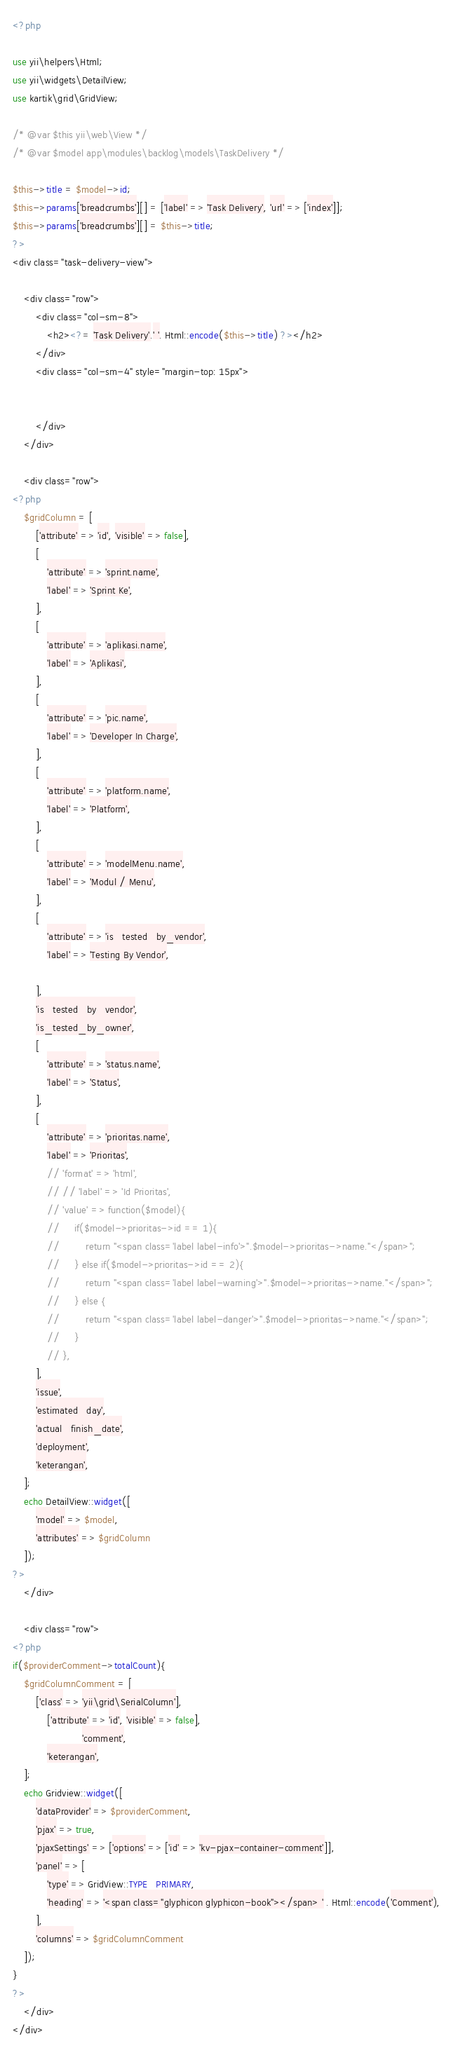<code> <loc_0><loc_0><loc_500><loc_500><_PHP_><?php

use yii\helpers\Html;
use yii\widgets\DetailView;
use kartik\grid\GridView;

/* @var $this yii\web\View */
/* @var $model app\modules\backlog\models\TaskDelivery */

$this->title = $model->id;
$this->params['breadcrumbs'][] = ['label' => 'Task Delivery', 'url' => ['index']];
$this->params['breadcrumbs'][] = $this->title;
?>
<div class="task-delivery-view">

    <div class="row">
        <div class="col-sm-8">
            <h2><?= 'Task Delivery'.' '. Html::encode($this->title) ?></h2>
        </div>
        <div class="col-sm-4" style="margin-top: 15px">

            
        </div>
    </div>

    <div class="row">
<?php 
    $gridColumn = [
        ['attribute' => 'id', 'visible' => false],
        [
            'attribute' => 'sprint.name',
            'label' => 'Sprint Ke',
        ],
        [
            'attribute' => 'aplikasi.name',
            'label' => 'Aplikasi',
        ],
        [
            'attribute' => 'pic.name',
            'label' => 'Developer In Charge',
        ],
        [
            'attribute' => 'platform.name',
            'label' => 'Platform',
        ],
        [
            'attribute' => 'modelMenu.name',
            'label' => 'Modul / Menu',
        ],
        [
            'attribute' => 'is_tested_by_vendor',
            'label' => 'Testing By Vendor',
            
        ],
        'is_tested_by_vendor',
        'is_tested_by_owner',
        [
            'attribute' => 'status.name',
            'label' => 'Status',
        ],
        [
            'attribute' => 'prioritas.name',
            'label' => 'Prioritas',
            // 'format' => 'html',
            // // 'label' => 'Id Prioritas',
            // 'value' => function($model){
            //     if($model->prioritas->id == 1){
            //         return "<span class='label label-info'>".$model->prioritas->name."</span>";
            //     } else if($model->prioritas->id == 2){
            //         return "<span class='label label-warning'>".$model->prioritas->name."</span>";
            //     } else {
            //         return "<span class='label label-danger'>".$model->prioritas->name."</span>";
            //     }
            // },
        ],
        'issue',
        'estimated_day',
        'actual_finish_date',
        'deployment',
        'keterangan',
    ];
    echo DetailView::widget([
        'model' => $model,
        'attributes' => $gridColumn
    ]); 
?>
    </div>
    
    <div class="row">
<?php
if($providerComment->totalCount){
    $gridColumnComment = [
        ['class' => 'yii\grid\SerialColumn'],
            ['attribute' => 'id', 'visible' => false],
                        'comment',
            'keterangan',
    ];
    echo Gridview::widget([
        'dataProvider' => $providerComment,
        'pjax' => true,
        'pjaxSettings' => ['options' => ['id' => 'kv-pjax-container-comment']],
        'panel' => [
            'type' => GridView::TYPE_PRIMARY,
            'heading' => '<span class="glyphicon glyphicon-book"></span> ' . Html::encode('Comment'),
        ],
        'columns' => $gridColumnComment
    ]);
}
?>
    </div>
</div>
</code> 